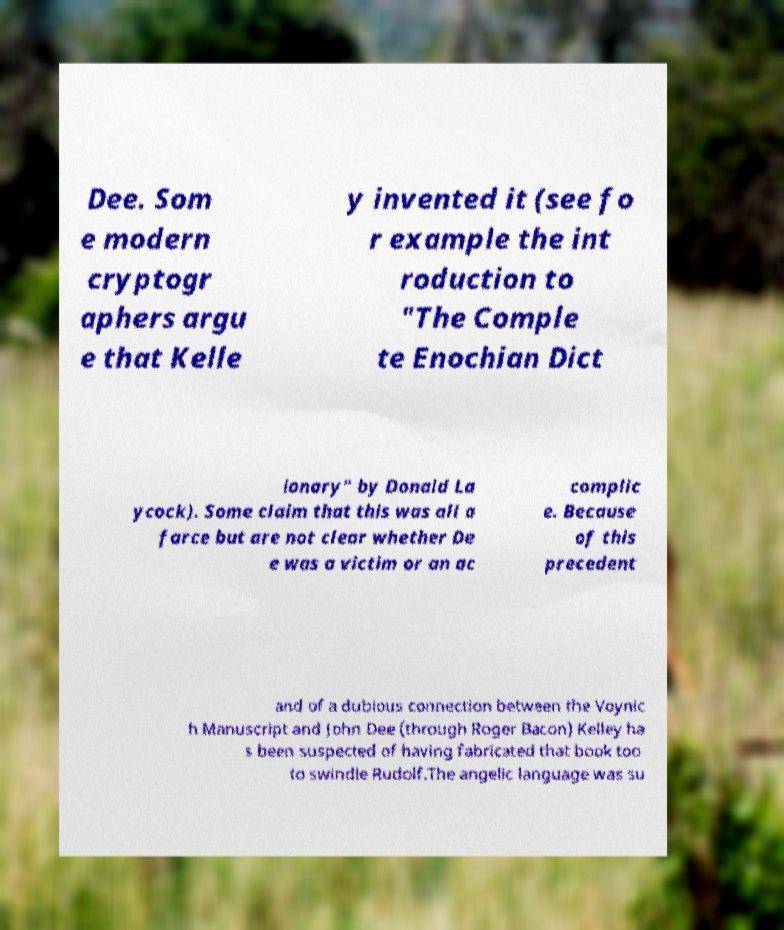Please identify and transcribe the text found in this image. Dee. Som e modern cryptogr aphers argu e that Kelle y invented it (see fo r example the int roduction to "The Comple te Enochian Dict ionary" by Donald La ycock). Some claim that this was all a farce but are not clear whether De e was a victim or an ac complic e. Because of this precedent and of a dubious connection between the Voynic h Manuscript and John Dee (through Roger Bacon) Kelley ha s been suspected of having fabricated that book too to swindle Rudolf.The angelic language was su 